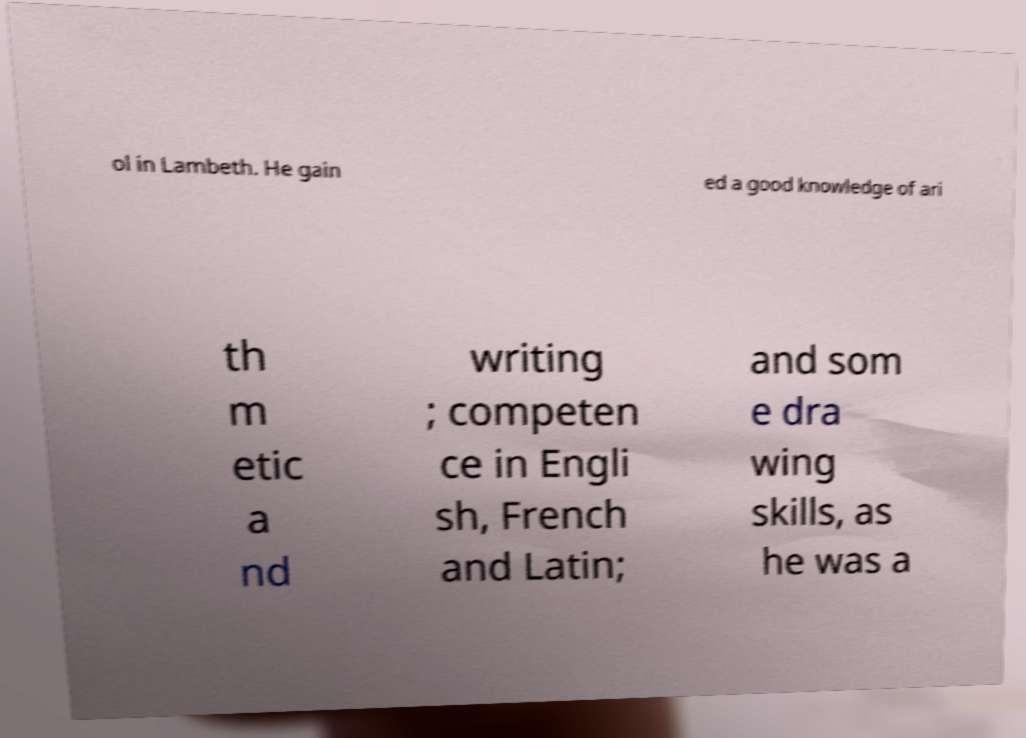Could you extract and type out the text from this image? ol in Lambeth. He gain ed a good knowledge of ari th m etic a nd writing ; competen ce in Engli sh, French and Latin; and som e dra wing skills, as he was a 